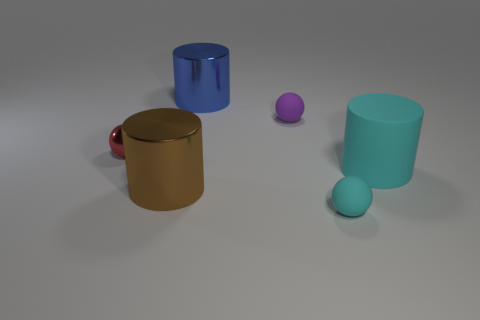Is there another rubber thing of the same shape as the brown object?
Make the answer very short. Yes. There is a matte ball that is behind the matte sphere that is in front of the small object to the left of the purple rubber ball; what is its size?
Provide a short and direct response. Small. Are there the same number of tiny spheres to the right of the cyan ball and red things behind the blue metal thing?
Keep it short and to the point. Yes. What size is the red sphere that is made of the same material as the brown cylinder?
Provide a short and direct response. Small. The big matte cylinder is what color?
Make the answer very short. Cyan. How many rubber cylinders are the same color as the tiny metallic ball?
Offer a very short reply. 0. What is the material of the purple object that is the same size as the cyan sphere?
Ensure brevity in your answer.  Rubber. There is a cyan matte cylinder in front of the purple rubber sphere; is there a tiny red metal sphere behind it?
Your answer should be compact. Yes. What number of other objects are the same color as the matte cylinder?
Give a very brief answer. 1. The matte cylinder is what size?
Your answer should be very brief. Large. 